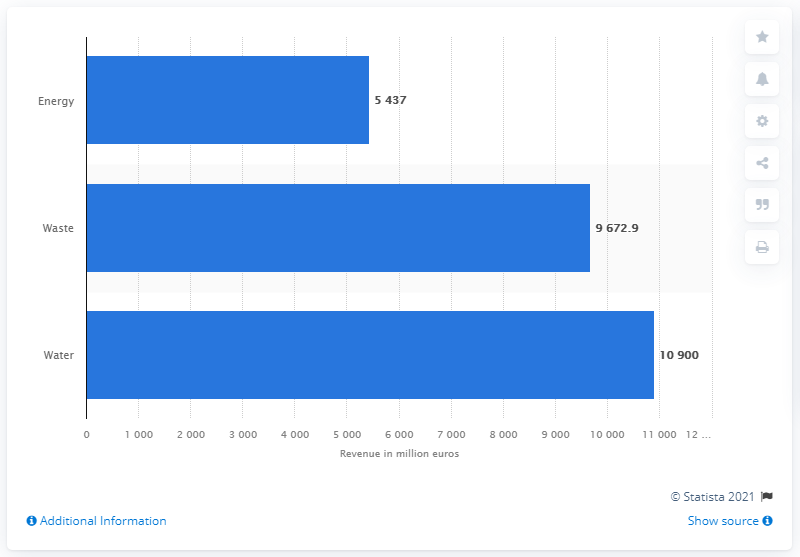Mention a couple of crucial points in this snapshot. Veolia Environnement's water revenue in the fiscal year of 2019 was 10,900. Veolia Environnement's waste division's revenue in the fiscal year of 2019 was 96,729. 